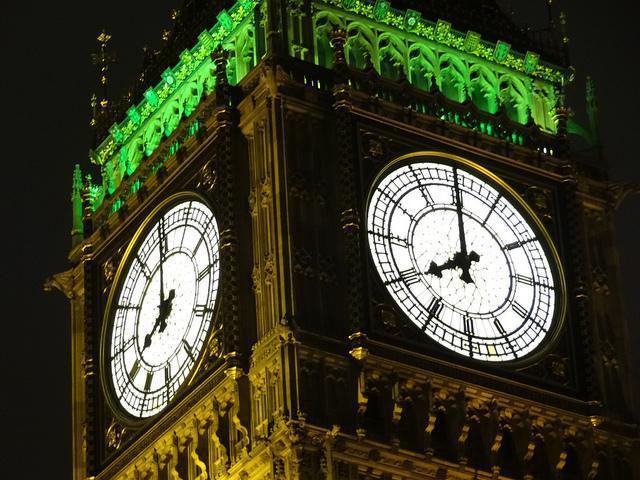How many clocks can you see?
Give a very brief answer. 2. How many people are on the left of bus?
Give a very brief answer. 0. 